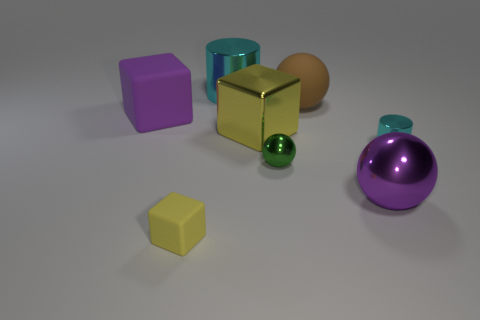What is the size of the thing that is left of the large metal cylinder and in front of the large yellow metallic cube?
Ensure brevity in your answer.  Small. Do the yellow rubber thing and the purple block have the same size?
Your response must be concise. No. Does the rubber block that is left of the tiny matte block have the same color as the shiny block?
Offer a terse response. No. How many brown rubber spheres are left of the small sphere?
Your answer should be compact. 0. Is the number of tiny cyan shiny cylinders greater than the number of brown cylinders?
Give a very brief answer. Yes. There is a rubber thing that is both left of the large brown object and behind the small cylinder; what is its shape?
Give a very brief answer. Cube. Are there any large blue rubber objects?
Ensure brevity in your answer.  No. There is a brown object that is the same shape as the big purple metallic thing; what material is it?
Make the answer very short. Rubber. What is the shape of the cyan shiny thing that is behind the cyan metallic cylinder that is to the right of the cyan cylinder that is on the left side of the big purple shiny sphere?
Provide a short and direct response. Cylinder. There is a tiny object that is the same color as the big metallic block; what is it made of?
Keep it short and to the point. Rubber. 